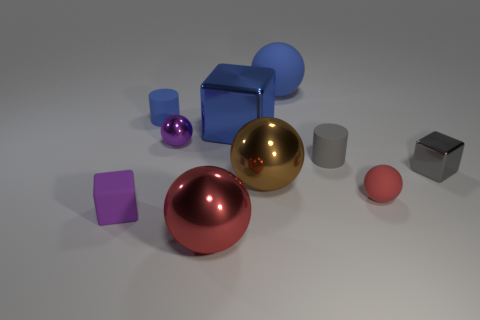There is a rubber sphere behind the red rubber thing; is it the same size as the red thing that is on the left side of the gray matte cylinder?
Provide a short and direct response. Yes. How many blocks are on the right side of the tiny blue cylinder and on the left side of the large red metallic ball?
Offer a terse response. 0. What color is the other small rubber object that is the same shape as the tiny blue rubber thing?
Your response must be concise. Gray. Is the number of large objects less than the number of green cylinders?
Your answer should be compact. No. Do the blue metal thing and the cylinder that is to the right of the tiny blue rubber object have the same size?
Your answer should be compact. No. What color is the tiny object that is behind the metallic block on the left side of the red rubber ball?
Offer a terse response. Blue. What number of things are tiny cylinders that are on the right side of the big metallic cube or small things that are in front of the small blue rubber cylinder?
Your response must be concise. 5. Is the size of the brown metallic object the same as the gray matte thing?
Provide a short and direct response. No. Is there any other thing that has the same size as the gray metal thing?
Give a very brief answer. Yes. Do the small metal object that is to the left of the tiny red matte thing and the tiny metallic object in front of the small purple ball have the same shape?
Offer a terse response. No. 